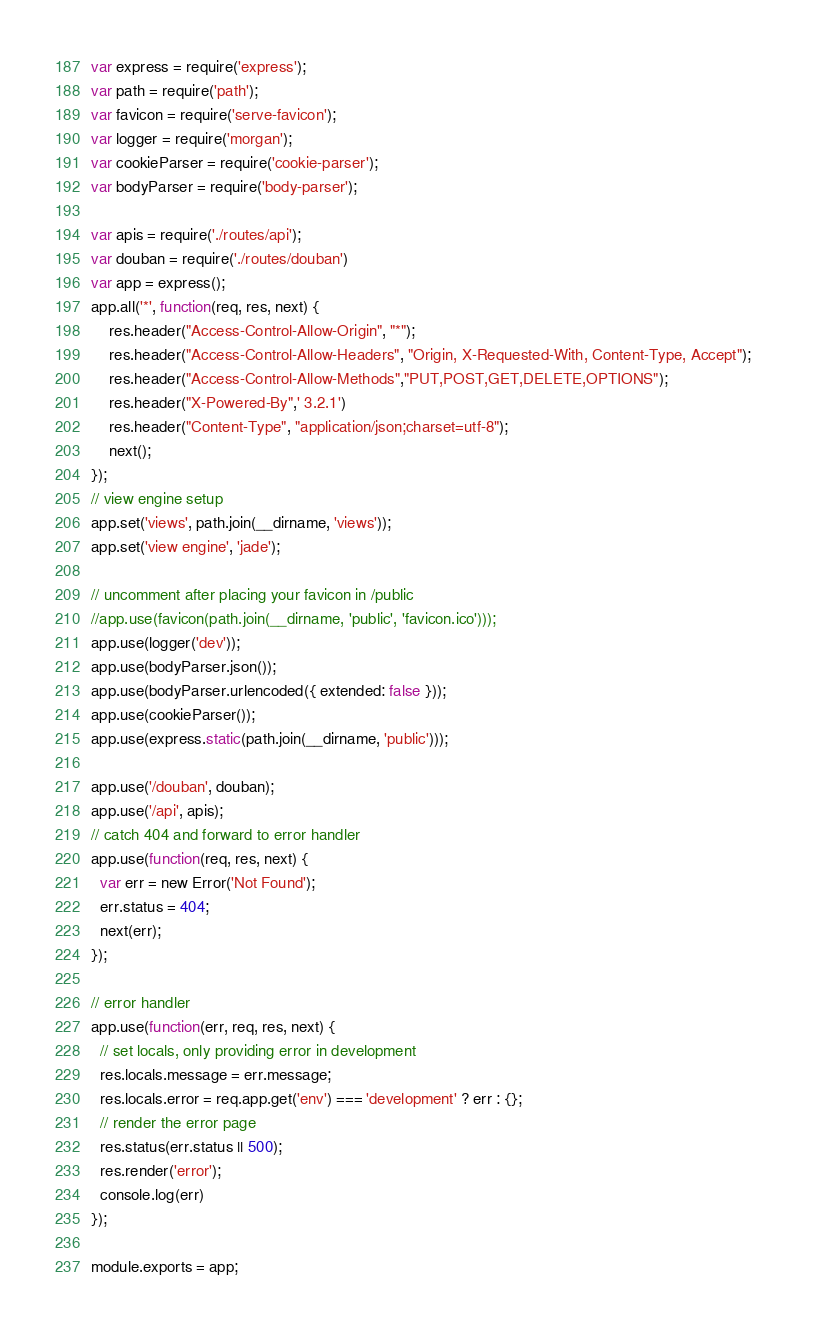Convert code to text. <code><loc_0><loc_0><loc_500><loc_500><_JavaScript_>var express = require('express');
var path = require('path');
var favicon = require('serve-favicon');
var logger = require('morgan');
var cookieParser = require('cookie-parser');
var bodyParser = require('body-parser');

var apis = require('./routes/api');
var douban = require('./routes/douban')
var app = express();
app.all('*', function(req, res, next) {  
    res.header("Access-Control-Allow-Origin", "*");  
    res.header("Access-Control-Allow-Headers", "Origin, X-Requested-With, Content-Type, Accept");  
    res.header("Access-Control-Allow-Methods","PUT,POST,GET,DELETE,OPTIONS");  
    res.header("X-Powered-By",' 3.2.1')  
    res.header("Content-Type", "application/json;charset=utf-8");  
    next();  
}); 
// view engine setup
app.set('views', path.join(__dirname, 'views'));
app.set('view engine', 'jade');

// uncomment after placing your favicon in /public
//app.use(favicon(path.join(__dirname, 'public', 'favicon.ico')));
app.use(logger('dev'));
app.use(bodyParser.json());
app.use(bodyParser.urlencoded({ extended: false }));
app.use(cookieParser());
app.use(express.static(path.join(__dirname, 'public')));

app.use('/douban', douban);
app.use('/api', apis);
// catch 404 and forward to error handler
app.use(function(req, res, next) {
  var err = new Error('Not Found');
  err.status = 404;
  next(err);
});

// error handler
app.use(function(err, req, res, next) {
  // set locals, only providing error in development
  res.locals.message = err.message;
  res.locals.error = req.app.get('env') === 'development' ? err : {};
  // render the error page
  res.status(err.status || 500);
  res.render('error');
  console.log(err)
});

module.exports = app;
</code> 